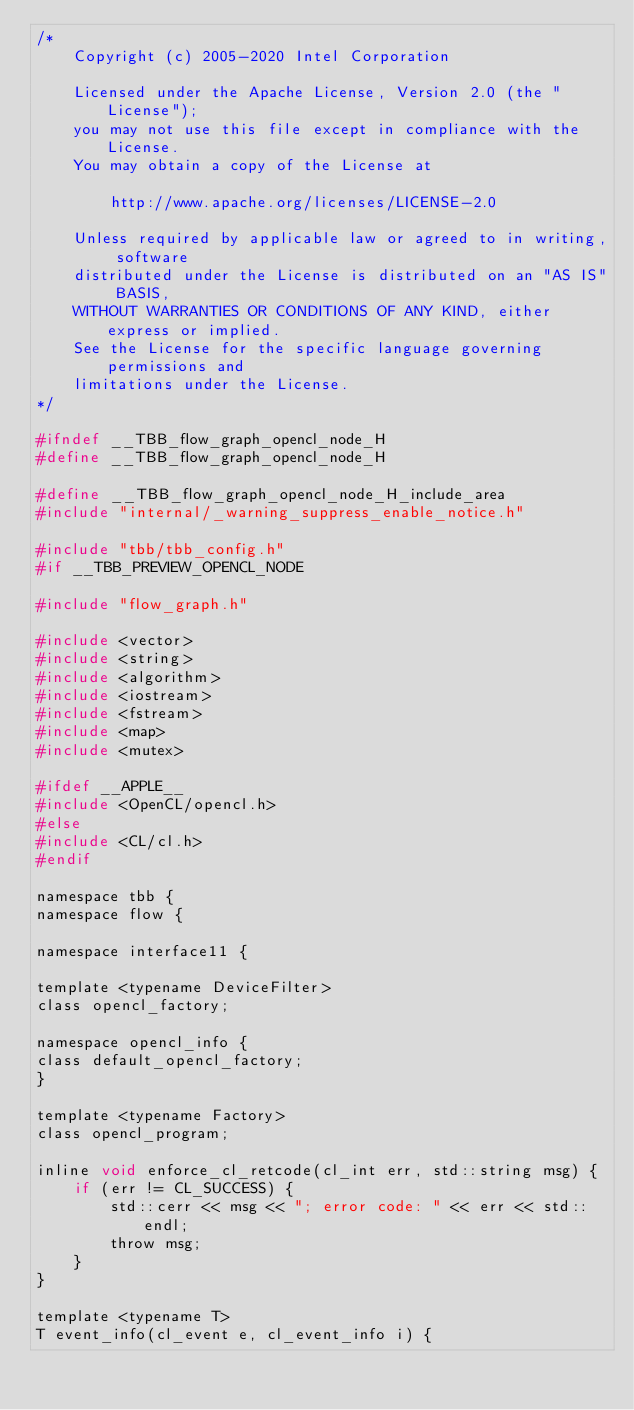Convert code to text. <code><loc_0><loc_0><loc_500><loc_500><_C_>/*
    Copyright (c) 2005-2020 Intel Corporation

    Licensed under the Apache License, Version 2.0 (the "License");
    you may not use this file except in compliance with the License.
    You may obtain a copy of the License at

        http://www.apache.org/licenses/LICENSE-2.0

    Unless required by applicable law or agreed to in writing, software
    distributed under the License is distributed on an "AS IS" BASIS,
    WITHOUT WARRANTIES OR CONDITIONS OF ANY KIND, either express or implied.
    See the License for the specific language governing permissions and
    limitations under the License.
*/

#ifndef __TBB_flow_graph_opencl_node_H
#define __TBB_flow_graph_opencl_node_H

#define __TBB_flow_graph_opencl_node_H_include_area
#include "internal/_warning_suppress_enable_notice.h"

#include "tbb/tbb_config.h"
#if __TBB_PREVIEW_OPENCL_NODE

#include "flow_graph.h"

#include <vector>
#include <string>
#include <algorithm>
#include <iostream>
#include <fstream>
#include <map>
#include <mutex>

#ifdef __APPLE__
#include <OpenCL/opencl.h>
#else
#include <CL/cl.h>
#endif

namespace tbb {
namespace flow {

namespace interface11 {

template <typename DeviceFilter>
class opencl_factory;

namespace opencl_info {
class default_opencl_factory;
}

template <typename Factory>
class opencl_program;

inline void enforce_cl_retcode(cl_int err, std::string msg) {
    if (err != CL_SUCCESS) {
        std::cerr << msg << "; error code: " << err << std::endl;
        throw msg;
    }
}

template <typename T>
T event_info(cl_event e, cl_event_info i) {</code> 